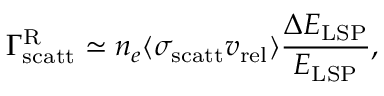<formula> <loc_0><loc_0><loc_500><loc_500>\Gamma _ { s c a t t } ^ { R } \simeq n _ { e } \langle \sigma _ { s c a t t } v _ { r e l } \rangle \frac { \Delta E _ { L S P } } { E _ { L S P } } ,</formula> 